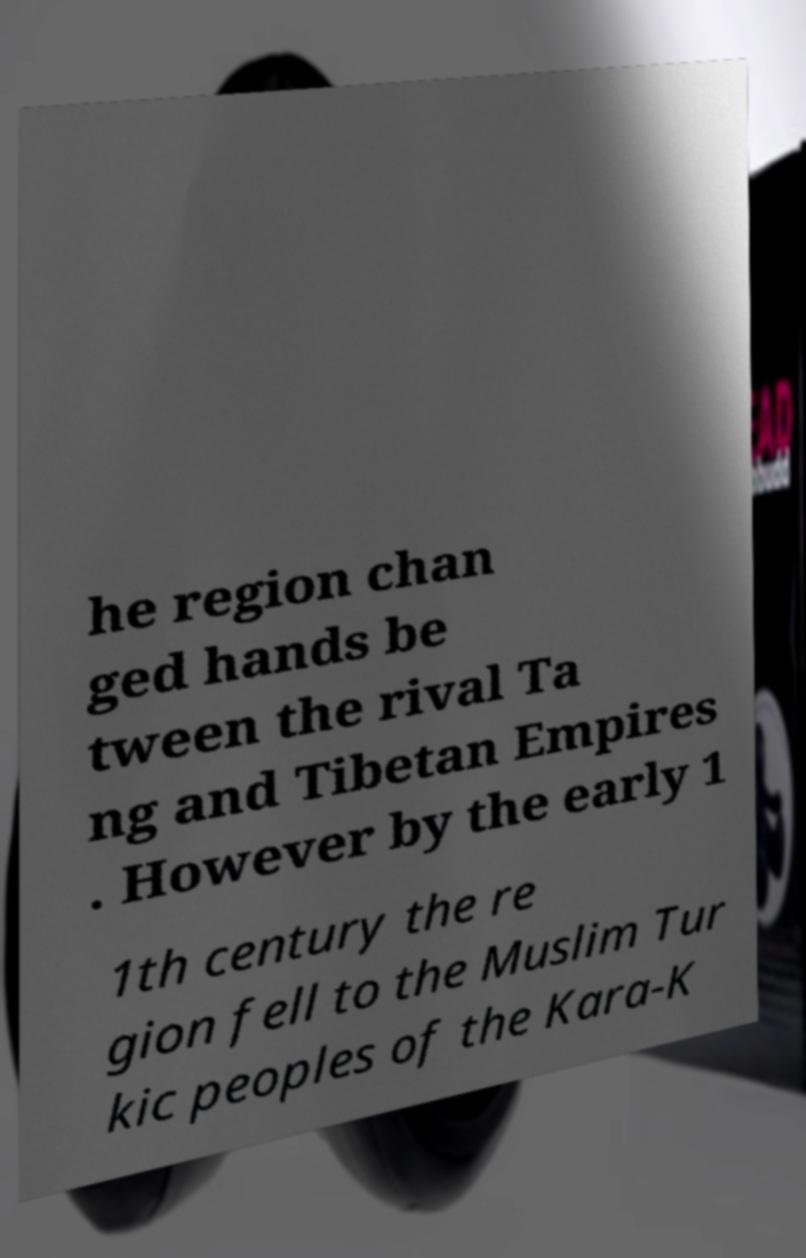Please identify and transcribe the text found in this image. he region chan ged hands be tween the rival Ta ng and Tibetan Empires . However by the early 1 1th century the re gion fell to the Muslim Tur kic peoples of the Kara-K 